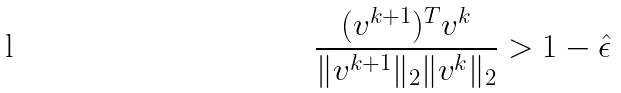Convert formula to latex. <formula><loc_0><loc_0><loc_500><loc_500>\frac { ( v ^ { k + 1 } ) ^ { T } v ^ { k } } { \| v ^ { k + 1 } \| _ { 2 } \| v ^ { k } \| _ { 2 } } > 1 - \hat { \epsilon }</formula> 